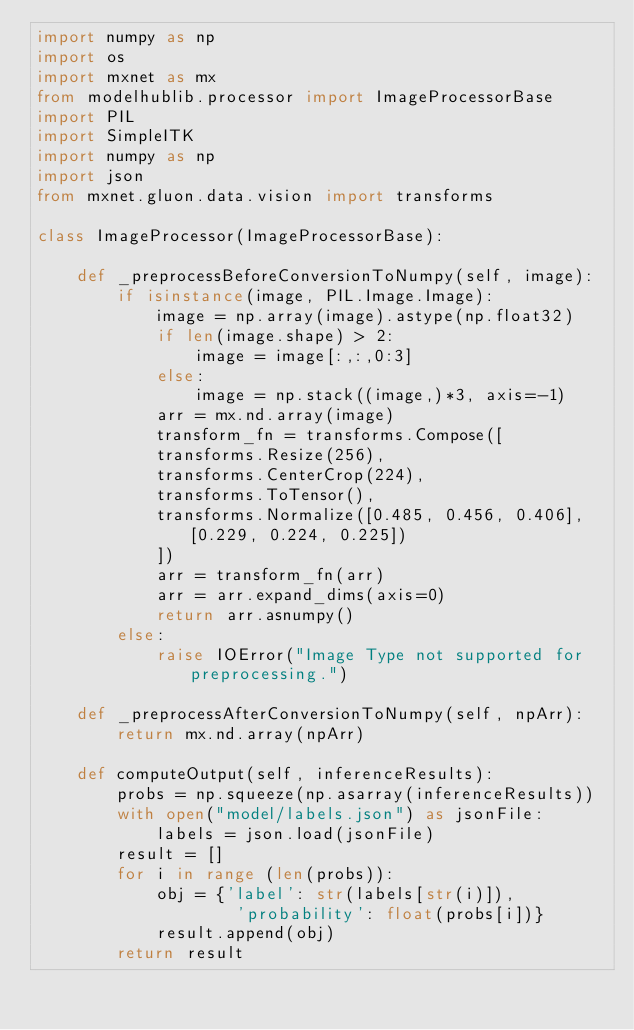<code> <loc_0><loc_0><loc_500><loc_500><_Python_>import numpy as np
import os
import mxnet as mx
from modelhublib.processor import ImageProcessorBase
import PIL
import SimpleITK
import numpy as np
import json
from mxnet.gluon.data.vision import transforms

class ImageProcessor(ImageProcessorBase):

    def _preprocessBeforeConversionToNumpy(self, image):
        if isinstance(image, PIL.Image.Image):
            image = np.array(image).astype(np.float32)
            if len(image.shape) > 2:
                image = image[:,:,0:3]
            else:
                image = np.stack((image,)*3, axis=-1)
            arr = mx.nd.array(image)
            transform_fn = transforms.Compose([
            transforms.Resize(256),
            transforms.CenterCrop(224),
            transforms.ToTensor(),
            transforms.Normalize([0.485, 0.456, 0.406], [0.229, 0.224, 0.225])
            ])
            arr = transform_fn(arr)
            arr = arr.expand_dims(axis=0)
            return arr.asnumpy()
        else:
            raise IOError("Image Type not supported for preprocessing.")

    def _preprocessAfterConversionToNumpy(self, npArr):
        return mx.nd.array(npArr)

    def computeOutput(self, inferenceResults):
        probs = np.squeeze(np.asarray(inferenceResults))
        with open("model/labels.json") as jsonFile:
            labels = json.load(jsonFile)
        result = []
        for i in range (len(probs)):
            obj = {'label': str(labels[str(i)]),
                    'probability': float(probs[i])}
            result.append(obj)
        return result
</code> 